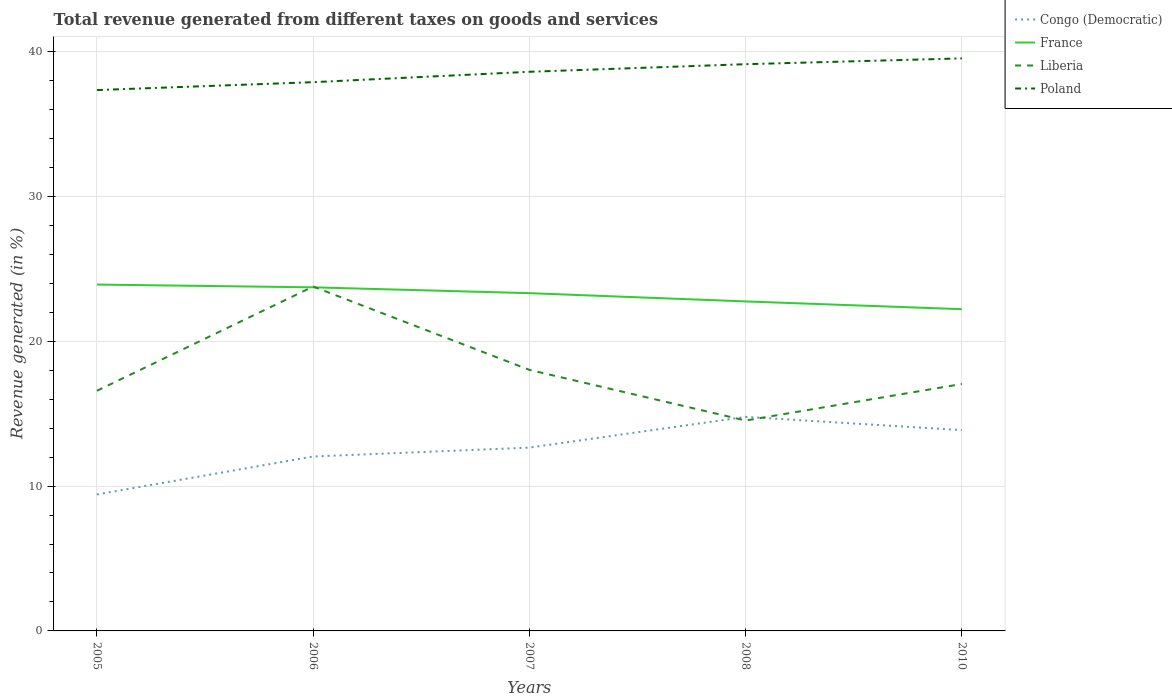Across all years, what is the maximum total revenue generated in Congo (Democratic)?
Keep it short and to the point. 9.42. What is the total total revenue generated in Liberia in the graph?
Provide a succinct answer. 2.06. What is the difference between the highest and the second highest total revenue generated in Poland?
Make the answer very short. 2.19. Is the total revenue generated in Congo (Democratic) strictly greater than the total revenue generated in Poland over the years?
Give a very brief answer. Yes. How many years are there in the graph?
Your answer should be very brief. 5. What is the difference between two consecutive major ticks on the Y-axis?
Make the answer very short. 10. Does the graph contain any zero values?
Make the answer very short. No. How are the legend labels stacked?
Ensure brevity in your answer.  Vertical. What is the title of the graph?
Ensure brevity in your answer.  Total revenue generated from different taxes on goods and services. What is the label or title of the Y-axis?
Your response must be concise. Revenue generated (in %). What is the Revenue generated (in %) in Congo (Democratic) in 2005?
Your answer should be very brief. 9.42. What is the Revenue generated (in %) in France in 2005?
Offer a very short reply. 23.91. What is the Revenue generated (in %) of Liberia in 2005?
Your answer should be compact. 16.58. What is the Revenue generated (in %) in Poland in 2005?
Offer a very short reply. 37.34. What is the Revenue generated (in %) of Congo (Democratic) in 2006?
Keep it short and to the point. 12.04. What is the Revenue generated (in %) in France in 2006?
Provide a short and direct response. 23.72. What is the Revenue generated (in %) of Liberia in 2006?
Offer a terse response. 23.77. What is the Revenue generated (in %) of Poland in 2006?
Keep it short and to the point. 37.88. What is the Revenue generated (in %) in Congo (Democratic) in 2007?
Keep it short and to the point. 12.66. What is the Revenue generated (in %) of France in 2007?
Offer a terse response. 23.32. What is the Revenue generated (in %) in Liberia in 2007?
Your response must be concise. 18.02. What is the Revenue generated (in %) of Poland in 2007?
Offer a very short reply. 38.6. What is the Revenue generated (in %) in Congo (Democratic) in 2008?
Provide a short and direct response. 14.78. What is the Revenue generated (in %) in France in 2008?
Keep it short and to the point. 22.75. What is the Revenue generated (in %) of Liberia in 2008?
Ensure brevity in your answer.  14.52. What is the Revenue generated (in %) in Poland in 2008?
Your response must be concise. 39.12. What is the Revenue generated (in %) in Congo (Democratic) in 2010?
Provide a succinct answer. 13.86. What is the Revenue generated (in %) of France in 2010?
Provide a succinct answer. 22.21. What is the Revenue generated (in %) in Liberia in 2010?
Your answer should be compact. 17.05. What is the Revenue generated (in %) of Poland in 2010?
Your response must be concise. 39.52. Across all years, what is the maximum Revenue generated (in %) in Congo (Democratic)?
Give a very brief answer. 14.78. Across all years, what is the maximum Revenue generated (in %) of France?
Make the answer very short. 23.91. Across all years, what is the maximum Revenue generated (in %) of Liberia?
Make the answer very short. 23.77. Across all years, what is the maximum Revenue generated (in %) in Poland?
Offer a terse response. 39.52. Across all years, what is the minimum Revenue generated (in %) of Congo (Democratic)?
Offer a terse response. 9.42. Across all years, what is the minimum Revenue generated (in %) of France?
Provide a short and direct response. 22.21. Across all years, what is the minimum Revenue generated (in %) of Liberia?
Give a very brief answer. 14.52. Across all years, what is the minimum Revenue generated (in %) of Poland?
Provide a short and direct response. 37.34. What is the total Revenue generated (in %) of Congo (Democratic) in the graph?
Provide a short and direct response. 62.75. What is the total Revenue generated (in %) of France in the graph?
Ensure brevity in your answer.  115.9. What is the total Revenue generated (in %) of Liberia in the graph?
Keep it short and to the point. 89.94. What is the total Revenue generated (in %) in Poland in the graph?
Make the answer very short. 192.46. What is the difference between the Revenue generated (in %) of Congo (Democratic) in 2005 and that in 2006?
Your response must be concise. -2.62. What is the difference between the Revenue generated (in %) in France in 2005 and that in 2006?
Your answer should be compact. 0.19. What is the difference between the Revenue generated (in %) of Liberia in 2005 and that in 2006?
Your answer should be very brief. -7.19. What is the difference between the Revenue generated (in %) of Poland in 2005 and that in 2006?
Ensure brevity in your answer.  -0.54. What is the difference between the Revenue generated (in %) in Congo (Democratic) in 2005 and that in 2007?
Your answer should be very brief. -3.23. What is the difference between the Revenue generated (in %) in France in 2005 and that in 2007?
Your answer should be very brief. 0.59. What is the difference between the Revenue generated (in %) of Liberia in 2005 and that in 2007?
Your answer should be very brief. -1.44. What is the difference between the Revenue generated (in %) of Poland in 2005 and that in 2007?
Offer a terse response. -1.26. What is the difference between the Revenue generated (in %) in Congo (Democratic) in 2005 and that in 2008?
Your answer should be compact. -5.35. What is the difference between the Revenue generated (in %) in France in 2005 and that in 2008?
Keep it short and to the point. 1.16. What is the difference between the Revenue generated (in %) of Liberia in 2005 and that in 2008?
Give a very brief answer. 2.06. What is the difference between the Revenue generated (in %) in Poland in 2005 and that in 2008?
Your answer should be compact. -1.79. What is the difference between the Revenue generated (in %) of Congo (Democratic) in 2005 and that in 2010?
Offer a terse response. -4.44. What is the difference between the Revenue generated (in %) of France in 2005 and that in 2010?
Keep it short and to the point. 1.7. What is the difference between the Revenue generated (in %) of Liberia in 2005 and that in 2010?
Keep it short and to the point. -0.47. What is the difference between the Revenue generated (in %) in Poland in 2005 and that in 2010?
Ensure brevity in your answer.  -2.19. What is the difference between the Revenue generated (in %) of Congo (Democratic) in 2006 and that in 2007?
Provide a short and direct response. -0.62. What is the difference between the Revenue generated (in %) in France in 2006 and that in 2007?
Give a very brief answer. 0.4. What is the difference between the Revenue generated (in %) in Liberia in 2006 and that in 2007?
Offer a very short reply. 5.75. What is the difference between the Revenue generated (in %) of Poland in 2006 and that in 2007?
Offer a terse response. -0.72. What is the difference between the Revenue generated (in %) of Congo (Democratic) in 2006 and that in 2008?
Your answer should be very brief. -2.74. What is the difference between the Revenue generated (in %) of France in 2006 and that in 2008?
Your answer should be very brief. 0.97. What is the difference between the Revenue generated (in %) in Liberia in 2006 and that in 2008?
Give a very brief answer. 9.25. What is the difference between the Revenue generated (in %) in Poland in 2006 and that in 2008?
Give a very brief answer. -1.24. What is the difference between the Revenue generated (in %) of Congo (Democratic) in 2006 and that in 2010?
Provide a succinct answer. -1.82. What is the difference between the Revenue generated (in %) in France in 2006 and that in 2010?
Provide a short and direct response. 1.51. What is the difference between the Revenue generated (in %) in Liberia in 2006 and that in 2010?
Make the answer very short. 6.73. What is the difference between the Revenue generated (in %) of Poland in 2006 and that in 2010?
Your response must be concise. -1.64. What is the difference between the Revenue generated (in %) in Congo (Democratic) in 2007 and that in 2008?
Provide a succinct answer. -2.12. What is the difference between the Revenue generated (in %) in France in 2007 and that in 2008?
Offer a very short reply. 0.57. What is the difference between the Revenue generated (in %) of Liberia in 2007 and that in 2008?
Provide a succinct answer. 3.5. What is the difference between the Revenue generated (in %) of Poland in 2007 and that in 2008?
Ensure brevity in your answer.  -0.52. What is the difference between the Revenue generated (in %) of Congo (Democratic) in 2007 and that in 2010?
Your response must be concise. -1.21. What is the difference between the Revenue generated (in %) in France in 2007 and that in 2010?
Offer a very short reply. 1.11. What is the difference between the Revenue generated (in %) in Liberia in 2007 and that in 2010?
Your answer should be compact. 0.97. What is the difference between the Revenue generated (in %) of Poland in 2007 and that in 2010?
Your answer should be very brief. -0.93. What is the difference between the Revenue generated (in %) of Congo (Democratic) in 2008 and that in 2010?
Provide a succinct answer. 0.92. What is the difference between the Revenue generated (in %) in France in 2008 and that in 2010?
Make the answer very short. 0.54. What is the difference between the Revenue generated (in %) in Liberia in 2008 and that in 2010?
Make the answer very short. -2.52. What is the difference between the Revenue generated (in %) in Poland in 2008 and that in 2010?
Your answer should be very brief. -0.4. What is the difference between the Revenue generated (in %) of Congo (Democratic) in 2005 and the Revenue generated (in %) of France in 2006?
Give a very brief answer. -14.3. What is the difference between the Revenue generated (in %) in Congo (Democratic) in 2005 and the Revenue generated (in %) in Liberia in 2006?
Your answer should be very brief. -14.35. What is the difference between the Revenue generated (in %) in Congo (Democratic) in 2005 and the Revenue generated (in %) in Poland in 2006?
Your answer should be compact. -28.46. What is the difference between the Revenue generated (in %) in France in 2005 and the Revenue generated (in %) in Liberia in 2006?
Provide a short and direct response. 0.14. What is the difference between the Revenue generated (in %) in France in 2005 and the Revenue generated (in %) in Poland in 2006?
Your answer should be very brief. -13.97. What is the difference between the Revenue generated (in %) of Liberia in 2005 and the Revenue generated (in %) of Poland in 2006?
Provide a succinct answer. -21.3. What is the difference between the Revenue generated (in %) of Congo (Democratic) in 2005 and the Revenue generated (in %) of France in 2007?
Keep it short and to the point. -13.89. What is the difference between the Revenue generated (in %) of Congo (Democratic) in 2005 and the Revenue generated (in %) of Liberia in 2007?
Provide a short and direct response. -8.6. What is the difference between the Revenue generated (in %) in Congo (Democratic) in 2005 and the Revenue generated (in %) in Poland in 2007?
Your response must be concise. -29.18. What is the difference between the Revenue generated (in %) in France in 2005 and the Revenue generated (in %) in Liberia in 2007?
Keep it short and to the point. 5.89. What is the difference between the Revenue generated (in %) in France in 2005 and the Revenue generated (in %) in Poland in 2007?
Your answer should be compact. -14.69. What is the difference between the Revenue generated (in %) in Liberia in 2005 and the Revenue generated (in %) in Poland in 2007?
Give a very brief answer. -22.02. What is the difference between the Revenue generated (in %) in Congo (Democratic) in 2005 and the Revenue generated (in %) in France in 2008?
Provide a short and direct response. -13.32. What is the difference between the Revenue generated (in %) in Congo (Democratic) in 2005 and the Revenue generated (in %) in Liberia in 2008?
Keep it short and to the point. -5.1. What is the difference between the Revenue generated (in %) in Congo (Democratic) in 2005 and the Revenue generated (in %) in Poland in 2008?
Ensure brevity in your answer.  -29.7. What is the difference between the Revenue generated (in %) in France in 2005 and the Revenue generated (in %) in Liberia in 2008?
Offer a terse response. 9.39. What is the difference between the Revenue generated (in %) of France in 2005 and the Revenue generated (in %) of Poland in 2008?
Provide a short and direct response. -15.21. What is the difference between the Revenue generated (in %) in Liberia in 2005 and the Revenue generated (in %) in Poland in 2008?
Your response must be concise. -22.54. What is the difference between the Revenue generated (in %) in Congo (Democratic) in 2005 and the Revenue generated (in %) in France in 2010?
Give a very brief answer. -12.79. What is the difference between the Revenue generated (in %) in Congo (Democratic) in 2005 and the Revenue generated (in %) in Liberia in 2010?
Offer a terse response. -7.63. What is the difference between the Revenue generated (in %) of Congo (Democratic) in 2005 and the Revenue generated (in %) of Poland in 2010?
Keep it short and to the point. -30.1. What is the difference between the Revenue generated (in %) of France in 2005 and the Revenue generated (in %) of Liberia in 2010?
Ensure brevity in your answer.  6.86. What is the difference between the Revenue generated (in %) of France in 2005 and the Revenue generated (in %) of Poland in 2010?
Ensure brevity in your answer.  -15.61. What is the difference between the Revenue generated (in %) in Liberia in 2005 and the Revenue generated (in %) in Poland in 2010?
Your answer should be very brief. -22.94. What is the difference between the Revenue generated (in %) of Congo (Democratic) in 2006 and the Revenue generated (in %) of France in 2007?
Give a very brief answer. -11.28. What is the difference between the Revenue generated (in %) of Congo (Democratic) in 2006 and the Revenue generated (in %) of Liberia in 2007?
Your answer should be very brief. -5.98. What is the difference between the Revenue generated (in %) of Congo (Democratic) in 2006 and the Revenue generated (in %) of Poland in 2007?
Make the answer very short. -26.56. What is the difference between the Revenue generated (in %) of France in 2006 and the Revenue generated (in %) of Liberia in 2007?
Your answer should be very brief. 5.7. What is the difference between the Revenue generated (in %) in France in 2006 and the Revenue generated (in %) in Poland in 2007?
Your response must be concise. -14.88. What is the difference between the Revenue generated (in %) in Liberia in 2006 and the Revenue generated (in %) in Poland in 2007?
Offer a terse response. -14.83. What is the difference between the Revenue generated (in %) of Congo (Democratic) in 2006 and the Revenue generated (in %) of France in 2008?
Keep it short and to the point. -10.71. What is the difference between the Revenue generated (in %) in Congo (Democratic) in 2006 and the Revenue generated (in %) in Liberia in 2008?
Ensure brevity in your answer.  -2.48. What is the difference between the Revenue generated (in %) of Congo (Democratic) in 2006 and the Revenue generated (in %) of Poland in 2008?
Give a very brief answer. -27.08. What is the difference between the Revenue generated (in %) of France in 2006 and the Revenue generated (in %) of Liberia in 2008?
Provide a short and direct response. 9.2. What is the difference between the Revenue generated (in %) of France in 2006 and the Revenue generated (in %) of Poland in 2008?
Provide a succinct answer. -15.4. What is the difference between the Revenue generated (in %) of Liberia in 2006 and the Revenue generated (in %) of Poland in 2008?
Offer a very short reply. -15.35. What is the difference between the Revenue generated (in %) in Congo (Democratic) in 2006 and the Revenue generated (in %) in France in 2010?
Offer a very short reply. -10.17. What is the difference between the Revenue generated (in %) in Congo (Democratic) in 2006 and the Revenue generated (in %) in Liberia in 2010?
Keep it short and to the point. -5.01. What is the difference between the Revenue generated (in %) in Congo (Democratic) in 2006 and the Revenue generated (in %) in Poland in 2010?
Your answer should be compact. -27.48. What is the difference between the Revenue generated (in %) in France in 2006 and the Revenue generated (in %) in Liberia in 2010?
Make the answer very short. 6.67. What is the difference between the Revenue generated (in %) of France in 2006 and the Revenue generated (in %) of Poland in 2010?
Give a very brief answer. -15.8. What is the difference between the Revenue generated (in %) of Liberia in 2006 and the Revenue generated (in %) of Poland in 2010?
Ensure brevity in your answer.  -15.75. What is the difference between the Revenue generated (in %) of Congo (Democratic) in 2007 and the Revenue generated (in %) of France in 2008?
Make the answer very short. -10.09. What is the difference between the Revenue generated (in %) of Congo (Democratic) in 2007 and the Revenue generated (in %) of Liberia in 2008?
Ensure brevity in your answer.  -1.87. What is the difference between the Revenue generated (in %) of Congo (Democratic) in 2007 and the Revenue generated (in %) of Poland in 2008?
Offer a very short reply. -26.47. What is the difference between the Revenue generated (in %) in France in 2007 and the Revenue generated (in %) in Liberia in 2008?
Give a very brief answer. 8.79. What is the difference between the Revenue generated (in %) in France in 2007 and the Revenue generated (in %) in Poland in 2008?
Give a very brief answer. -15.81. What is the difference between the Revenue generated (in %) of Liberia in 2007 and the Revenue generated (in %) of Poland in 2008?
Keep it short and to the point. -21.1. What is the difference between the Revenue generated (in %) in Congo (Democratic) in 2007 and the Revenue generated (in %) in France in 2010?
Keep it short and to the point. -9.55. What is the difference between the Revenue generated (in %) of Congo (Democratic) in 2007 and the Revenue generated (in %) of Liberia in 2010?
Provide a short and direct response. -4.39. What is the difference between the Revenue generated (in %) of Congo (Democratic) in 2007 and the Revenue generated (in %) of Poland in 2010?
Make the answer very short. -26.87. What is the difference between the Revenue generated (in %) in France in 2007 and the Revenue generated (in %) in Liberia in 2010?
Offer a very short reply. 6.27. What is the difference between the Revenue generated (in %) of France in 2007 and the Revenue generated (in %) of Poland in 2010?
Offer a terse response. -16.21. What is the difference between the Revenue generated (in %) in Liberia in 2007 and the Revenue generated (in %) in Poland in 2010?
Offer a very short reply. -21.5. What is the difference between the Revenue generated (in %) of Congo (Democratic) in 2008 and the Revenue generated (in %) of France in 2010?
Your answer should be compact. -7.43. What is the difference between the Revenue generated (in %) in Congo (Democratic) in 2008 and the Revenue generated (in %) in Liberia in 2010?
Provide a short and direct response. -2.27. What is the difference between the Revenue generated (in %) in Congo (Democratic) in 2008 and the Revenue generated (in %) in Poland in 2010?
Provide a short and direct response. -24.75. What is the difference between the Revenue generated (in %) in France in 2008 and the Revenue generated (in %) in Liberia in 2010?
Give a very brief answer. 5.7. What is the difference between the Revenue generated (in %) in France in 2008 and the Revenue generated (in %) in Poland in 2010?
Keep it short and to the point. -16.78. What is the difference between the Revenue generated (in %) in Liberia in 2008 and the Revenue generated (in %) in Poland in 2010?
Make the answer very short. -25. What is the average Revenue generated (in %) in Congo (Democratic) per year?
Your response must be concise. 12.55. What is the average Revenue generated (in %) of France per year?
Give a very brief answer. 23.18. What is the average Revenue generated (in %) of Liberia per year?
Offer a very short reply. 17.99. What is the average Revenue generated (in %) in Poland per year?
Provide a short and direct response. 38.49. In the year 2005, what is the difference between the Revenue generated (in %) in Congo (Democratic) and Revenue generated (in %) in France?
Provide a succinct answer. -14.49. In the year 2005, what is the difference between the Revenue generated (in %) of Congo (Democratic) and Revenue generated (in %) of Liberia?
Your response must be concise. -7.16. In the year 2005, what is the difference between the Revenue generated (in %) of Congo (Democratic) and Revenue generated (in %) of Poland?
Make the answer very short. -27.91. In the year 2005, what is the difference between the Revenue generated (in %) of France and Revenue generated (in %) of Liberia?
Give a very brief answer. 7.33. In the year 2005, what is the difference between the Revenue generated (in %) in France and Revenue generated (in %) in Poland?
Ensure brevity in your answer.  -13.43. In the year 2005, what is the difference between the Revenue generated (in %) in Liberia and Revenue generated (in %) in Poland?
Keep it short and to the point. -20.76. In the year 2006, what is the difference between the Revenue generated (in %) of Congo (Democratic) and Revenue generated (in %) of France?
Your answer should be compact. -11.68. In the year 2006, what is the difference between the Revenue generated (in %) of Congo (Democratic) and Revenue generated (in %) of Liberia?
Offer a very short reply. -11.73. In the year 2006, what is the difference between the Revenue generated (in %) of Congo (Democratic) and Revenue generated (in %) of Poland?
Provide a succinct answer. -25.84. In the year 2006, what is the difference between the Revenue generated (in %) of France and Revenue generated (in %) of Liberia?
Your response must be concise. -0.05. In the year 2006, what is the difference between the Revenue generated (in %) in France and Revenue generated (in %) in Poland?
Provide a succinct answer. -14.16. In the year 2006, what is the difference between the Revenue generated (in %) in Liberia and Revenue generated (in %) in Poland?
Provide a succinct answer. -14.11. In the year 2007, what is the difference between the Revenue generated (in %) of Congo (Democratic) and Revenue generated (in %) of France?
Provide a short and direct response. -10.66. In the year 2007, what is the difference between the Revenue generated (in %) of Congo (Democratic) and Revenue generated (in %) of Liberia?
Provide a succinct answer. -5.37. In the year 2007, what is the difference between the Revenue generated (in %) in Congo (Democratic) and Revenue generated (in %) in Poland?
Offer a terse response. -25.94. In the year 2007, what is the difference between the Revenue generated (in %) of France and Revenue generated (in %) of Liberia?
Your response must be concise. 5.3. In the year 2007, what is the difference between the Revenue generated (in %) in France and Revenue generated (in %) in Poland?
Keep it short and to the point. -15.28. In the year 2007, what is the difference between the Revenue generated (in %) in Liberia and Revenue generated (in %) in Poland?
Provide a short and direct response. -20.58. In the year 2008, what is the difference between the Revenue generated (in %) of Congo (Democratic) and Revenue generated (in %) of France?
Your answer should be compact. -7.97. In the year 2008, what is the difference between the Revenue generated (in %) of Congo (Democratic) and Revenue generated (in %) of Liberia?
Provide a short and direct response. 0.25. In the year 2008, what is the difference between the Revenue generated (in %) of Congo (Democratic) and Revenue generated (in %) of Poland?
Your answer should be very brief. -24.35. In the year 2008, what is the difference between the Revenue generated (in %) of France and Revenue generated (in %) of Liberia?
Offer a terse response. 8.22. In the year 2008, what is the difference between the Revenue generated (in %) of France and Revenue generated (in %) of Poland?
Provide a succinct answer. -16.38. In the year 2008, what is the difference between the Revenue generated (in %) of Liberia and Revenue generated (in %) of Poland?
Offer a terse response. -24.6. In the year 2010, what is the difference between the Revenue generated (in %) in Congo (Democratic) and Revenue generated (in %) in France?
Give a very brief answer. -8.35. In the year 2010, what is the difference between the Revenue generated (in %) of Congo (Democratic) and Revenue generated (in %) of Liberia?
Provide a short and direct response. -3.19. In the year 2010, what is the difference between the Revenue generated (in %) in Congo (Democratic) and Revenue generated (in %) in Poland?
Offer a terse response. -25.66. In the year 2010, what is the difference between the Revenue generated (in %) in France and Revenue generated (in %) in Liberia?
Your answer should be compact. 5.16. In the year 2010, what is the difference between the Revenue generated (in %) of France and Revenue generated (in %) of Poland?
Give a very brief answer. -17.31. In the year 2010, what is the difference between the Revenue generated (in %) of Liberia and Revenue generated (in %) of Poland?
Provide a short and direct response. -22.48. What is the ratio of the Revenue generated (in %) in Congo (Democratic) in 2005 to that in 2006?
Give a very brief answer. 0.78. What is the ratio of the Revenue generated (in %) in France in 2005 to that in 2006?
Make the answer very short. 1.01. What is the ratio of the Revenue generated (in %) in Liberia in 2005 to that in 2006?
Offer a very short reply. 0.7. What is the ratio of the Revenue generated (in %) in Poland in 2005 to that in 2006?
Ensure brevity in your answer.  0.99. What is the ratio of the Revenue generated (in %) in Congo (Democratic) in 2005 to that in 2007?
Ensure brevity in your answer.  0.74. What is the ratio of the Revenue generated (in %) in France in 2005 to that in 2007?
Offer a terse response. 1.03. What is the ratio of the Revenue generated (in %) in Poland in 2005 to that in 2007?
Provide a succinct answer. 0.97. What is the ratio of the Revenue generated (in %) of Congo (Democratic) in 2005 to that in 2008?
Provide a short and direct response. 0.64. What is the ratio of the Revenue generated (in %) in France in 2005 to that in 2008?
Offer a terse response. 1.05. What is the ratio of the Revenue generated (in %) in Liberia in 2005 to that in 2008?
Give a very brief answer. 1.14. What is the ratio of the Revenue generated (in %) of Poland in 2005 to that in 2008?
Your answer should be very brief. 0.95. What is the ratio of the Revenue generated (in %) of Congo (Democratic) in 2005 to that in 2010?
Offer a terse response. 0.68. What is the ratio of the Revenue generated (in %) of France in 2005 to that in 2010?
Your answer should be compact. 1.08. What is the ratio of the Revenue generated (in %) of Liberia in 2005 to that in 2010?
Keep it short and to the point. 0.97. What is the ratio of the Revenue generated (in %) in Poland in 2005 to that in 2010?
Keep it short and to the point. 0.94. What is the ratio of the Revenue generated (in %) in Congo (Democratic) in 2006 to that in 2007?
Your response must be concise. 0.95. What is the ratio of the Revenue generated (in %) of France in 2006 to that in 2007?
Offer a terse response. 1.02. What is the ratio of the Revenue generated (in %) in Liberia in 2006 to that in 2007?
Offer a very short reply. 1.32. What is the ratio of the Revenue generated (in %) of Poland in 2006 to that in 2007?
Offer a very short reply. 0.98. What is the ratio of the Revenue generated (in %) of Congo (Democratic) in 2006 to that in 2008?
Your answer should be very brief. 0.81. What is the ratio of the Revenue generated (in %) of France in 2006 to that in 2008?
Give a very brief answer. 1.04. What is the ratio of the Revenue generated (in %) of Liberia in 2006 to that in 2008?
Your answer should be very brief. 1.64. What is the ratio of the Revenue generated (in %) of Poland in 2006 to that in 2008?
Your answer should be very brief. 0.97. What is the ratio of the Revenue generated (in %) of Congo (Democratic) in 2006 to that in 2010?
Your response must be concise. 0.87. What is the ratio of the Revenue generated (in %) of France in 2006 to that in 2010?
Provide a short and direct response. 1.07. What is the ratio of the Revenue generated (in %) of Liberia in 2006 to that in 2010?
Keep it short and to the point. 1.39. What is the ratio of the Revenue generated (in %) in Poland in 2006 to that in 2010?
Provide a succinct answer. 0.96. What is the ratio of the Revenue generated (in %) in Congo (Democratic) in 2007 to that in 2008?
Offer a terse response. 0.86. What is the ratio of the Revenue generated (in %) in France in 2007 to that in 2008?
Your answer should be very brief. 1.03. What is the ratio of the Revenue generated (in %) of Liberia in 2007 to that in 2008?
Your answer should be compact. 1.24. What is the ratio of the Revenue generated (in %) of Poland in 2007 to that in 2008?
Your response must be concise. 0.99. What is the ratio of the Revenue generated (in %) in Congo (Democratic) in 2007 to that in 2010?
Ensure brevity in your answer.  0.91. What is the ratio of the Revenue generated (in %) of France in 2007 to that in 2010?
Your answer should be compact. 1.05. What is the ratio of the Revenue generated (in %) of Liberia in 2007 to that in 2010?
Provide a short and direct response. 1.06. What is the ratio of the Revenue generated (in %) of Poland in 2007 to that in 2010?
Your response must be concise. 0.98. What is the ratio of the Revenue generated (in %) of Congo (Democratic) in 2008 to that in 2010?
Your answer should be compact. 1.07. What is the ratio of the Revenue generated (in %) of France in 2008 to that in 2010?
Offer a very short reply. 1.02. What is the ratio of the Revenue generated (in %) of Liberia in 2008 to that in 2010?
Provide a short and direct response. 0.85. What is the ratio of the Revenue generated (in %) of Poland in 2008 to that in 2010?
Offer a very short reply. 0.99. What is the difference between the highest and the second highest Revenue generated (in %) in Congo (Democratic)?
Your answer should be very brief. 0.92. What is the difference between the highest and the second highest Revenue generated (in %) of France?
Make the answer very short. 0.19. What is the difference between the highest and the second highest Revenue generated (in %) of Liberia?
Your response must be concise. 5.75. What is the difference between the highest and the second highest Revenue generated (in %) in Poland?
Your answer should be compact. 0.4. What is the difference between the highest and the lowest Revenue generated (in %) in Congo (Democratic)?
Provide a succinct answer. 5.35. What is the difference between the highest and the lowest Revenue generated (in %) in France?
Give a very brief answer. 1.7. What is the difference between the highest and the lowest Revenue generated (in %) in Liberia?
Keep it short and to the point. 9.25. What is the difference between the highest and the lowest Revenue generated (in %) in Poland?
Keep it short and to the point. 2.19. 